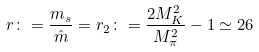<formula> <loc_0><loc_0><loc_500><loc_500>r \colon = \frac { m _ { s } } { \hat { m } } = r _ { 2 } \colon = \frac { 2 M _ { K } ^ { 2 } } { M _ { \pi } ^ { 2 } } - 1 \simeq 2 6</formula> 